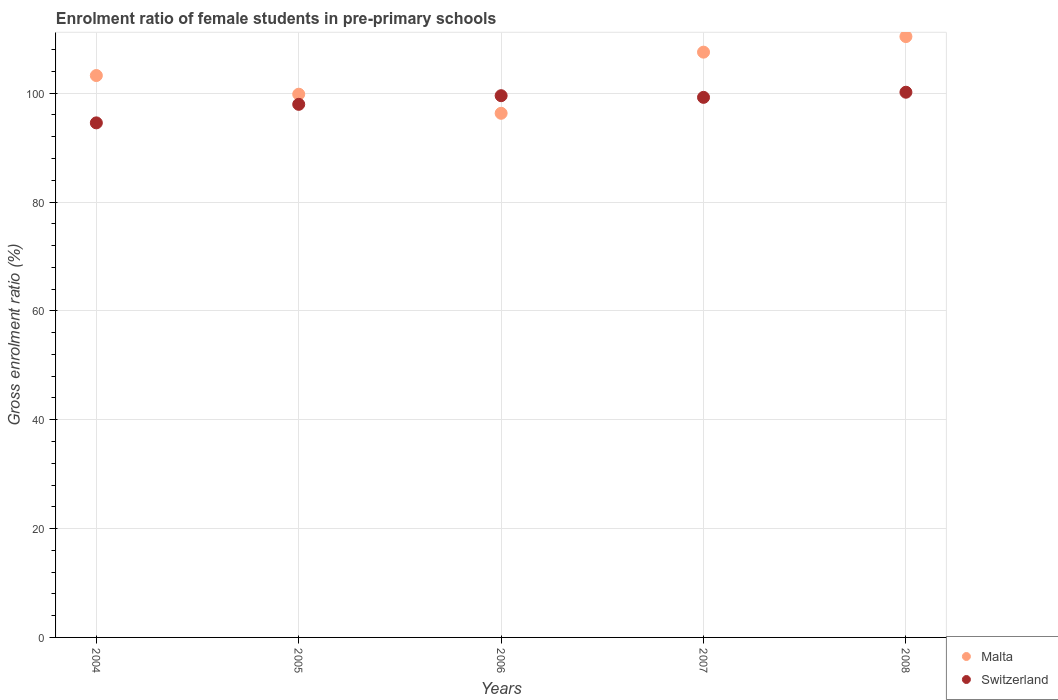How many different coloured dotlines are there?
Your answer should be very brief. 2. What is the enrolment ratio of female students in pre-primary schools in Switzerland in 2004?
Offer a very short reply. 94.55. Across all years, what is the maximum enrolment ratio of female students in pre-primary schools in Malta?
Make the answer very short. 110.4. Across all years, what is the minimum enrolment ratio of female students in pre-primary schools in Malta?
Make the answer very short. 96.31. In which year was the enrolment ratio of female students in pre-primary schools in Malta minimum?
Offer a terse response. 2006. What is the total enrolment ratio of female students in pre-primary schools in Malta in the graph?
Your answer should be compact. 517.31. What is the difference between the enrolment ratio of female students in pre-primary schools in Malta in 2005 and that in 2006?
Give a very brief answer. 3.51. What is the difference between the enrolment ratio of female students in pre-primary schools in Malta in 2006 and the enrolment ratio of female students in pre-primary schools in Switzerland in 2005?
Offer a terse response. -1.65. What is the average enrolment ratio of female students in pre-primary schools in Malta per year?
Offer a very short reply. 103.46. In the year 2004, what is the difference between the enrolment ratio of female students in pre-primary schools in Malta and enrolment ratio of female students in pre-primary schools in Switzerland?
Make the answer very short. 8.7. What is the ratio of the enrolment ratio of female students in pre-primary schools in Malta in 2004 to that in 2008?
Make the answer very short. 0.94. Is the enrolment ratio of female students in pre-primary schools in Malta in 2004 less than that in 2006?
Offer a very short reply. No. Is the difference between the enrolment ratio of female students in pre-primary schools in Malta in 2004 and 2006 greater than the difference between the enrolment ratio of female students in pre-primary schools in Switzerland in 2004 and 2006?
Give a very brief answer. Yes. What is the difference between the highest and the second highest enrolment ratio of female students in pre-primary schools in Malta?
Offer a very short reply. 2.86. What is the difference between the highest and the lowest enrolment ratio of female students in pre-primary schools in Switzerland?
Your response must be concise. 5.63. In how many years, is the enrolment ratio of female students in pre-primary schools in Switzerland greater than the average enrolment ratio of female students in pre-primary schools in Switzerland taken over all years?
Provide a short and direct response. 3. Is the sum of the enrolment ratio of female students in pre-primary schools in Switzerland in 2004 and 2008 greater than the maximum enrolment ratio of female students in pre-primary schools in Malta across all years?
Give a very brief answer. Yes. Is the enrolment ratio of female students in pre-primary schools in Malta strictly greater than the enrolment ratio of female students in pre-primary schools in Switzerland over the years?
Offer a very short reply. No. What is the difference between two consecutive major ticks on the Y-axis?
Your response must be concise. 20. What is the title of the graph?
Your response must be concise. Enrolment ratio of female students in pre-primary schools. What is the Gross enrolment ratio (%) in Malta in 2004?
Ensure brevity in your answer.  103.24. What is the Gross enrolment ratio (%) of Switzerland in 2004?
Ensure brevity in your answer.  94.55. What is the Gross enrolment ratio (%) of Malta in 2005?
Your answer should be very brief. 99.81. What is the Gross enrolment ratio (%) of Switzerland in 2005?
Make the answer very short. 97.95. What is the Gross enrolment ratio (%) in Malta in 2006?
Your answer should be compact. 96.31. What is the Gross enrolment ratio (%) of Switzerland in 2006?
Offer a terse response. 99.54. What is the Gross enrolment ratio (%) of Malta in 2007?
Give a very brief answer. 107.54. What is the Gross enrolment ratio (%) in Switzerland in 2007?
Give a very brief answer. 99.23. What is the Gross enrolment ratio (%) in Malta in 2008?
Provide a succinct answer. 110.4. What is the Gross enrolment ratio (%) in Switzerland in 2008?
Your answer should be compact. 100.18. Across all years, what is the maximum Gross enrolment ratio (%) of Malta?
Offer a terse response. 110.4. Across all years, what is the maximum Gross enrolment ratio (%) of Switzerland?
Offer a terse response. 100.18. Across all years, what is the minimum Gross enrolment ratio (%) of Malta?
Ensure brevity in your answer.  96.31. Across all years, what is the minimum Gross enrolment ratio (%) of Switzerland?
Keep it short and to the point. 94.55. What is the total Gross enrolment ratio (%) in Malta in the graph?
Provide a succinct answer. 517.31. What is the total Gross enrolment ratio (%) of Switzerland in the graph?
Give a very brief answer. 491.45. What is the difference between the Gross enrolment ratio (%) of Malta in 2004 and that in 2005?
Give a very brief answer. 3.43. What is the difference between the Gross enrolment ratio (%) in Switzerland in 2004 and that in 2005?
Make the answer very short. -3.4. What is the difference between the Gross enrolment ratio (%) of Malta in 2004 and that in 2006?
Make the answer very short. 6.94. What is the difference between the Gross enrolment ratio (%) in Switzerland in 2004 and that in 2006?
Give a very brief answer. -4.99. What is the difference between the Gross enrolment ratio (%) in Malta in 2004 and that in 2007?
Ensure brevity in your answer.  -4.3. What is the difference between the Gross enrolment ratio (%) in Switzerland in 2004 and that in 2007?
Offer a very short reply. -4.69. What is the difference between the Gross enrolment ratio (%) of Malta in 2004 and that in 2008?
Make the answer very short. -7.16. What is the difference between the Gross enrolment ratio (%) in Switzerland in 2004 and that in 2008?
Your answer should be compact. -5.63. What is the difference between the Gross enrolment ratio (%) of Malta in 2005 and that in 2006?
Your answer should be very brief. 3.51. What is the difference between the Gross enrolment ratio (%) in Switzerland in 2005 and that in 2006?
Keep it short and to the point. -1.59. What is the difference between the Gross enrolment ratio (%) in Malta in 2005 and that in 2007?
Your answer should be compact. -7.73. What is the difference between the Gross enrolment ratio (%) in Switzerland in 2005 and that in 2007?
Make the answer very short. -1.28. What is the difference between the Gross enrolment ratio (%) of Malta in 2005 and that in 2008?
Provide a succinct answer. -10.59. What is the difference between the Gross enrolment ratio (%) in Switzerland in 2005 and that in 2008?
Make the answer very short. -2.23. What is the difference between the Gross enrolment ratio (%) of Malta in 2006 and that in 2007?
Offer a very short reply. -11.24. What is the difference between the Gross enrolment ratio (%) in Switzerland in 2006 and that in 2007?
Provide a short and direct response. 0.31. What is the difference between the Gross enrolment ratio (%) of Malta in 2006 and that in 2008?
Make the answer very short. -14.1. What is the difference between the Gross enrolment ratio (%) in Switzerland in 2006 and that in 2008?
Provide a succinct answer. -0.64. What is the difference between the Gross enrolment ratio (%) in Malta in 2007 and that in 2008?
Ensure brevity in your answer.  -2.86. What is the difference between the Gross enrolment ratio (%) of Switzerland in 2007 and that in 2008?
Offer a very short reply. -0.94. What is the difference between the Gross enrolment ratio (%) in Malta in 2004 and the Gross enrolment ratio (%) in Switzerland in 2005?
Your answer should be compact. 5.29. What is the difference between the Gross enrolment ratio (%) of Malta in 2004 and the Gross enrolment ratio (%) of Switzerland in 2006?
Provide a succinct answer. 3.7. What is the difference between the Gross enrolment ratio (%) of Malta in 2004 and the Gross enrolment ratio (%) of Switzerland in 2007?
Offer a terse response. 4.01. What is the difference between the Gross enrolment ratio (%) in Malta in 2004 and the Gross enrolment ratio (%) in Switzerland in 2008?
Provide a succinct answer. 3.07. What is the difference between the Gross enrolment ratio (%) in Malta in 2005 and the Gross enrolment ratio (%) in Switzerland in 2006?
Your response must be concise. 0.27. What is the difference between the Gross enrolment ratio (%) in Malta in 2005 and the Gross enrolment ratio (%) in Switzerland in 2007?
Provide a short and direct response. 0.58. What is the difference between the Gross enrolment ratio (%) in Malta in 2005 and the Gross enrolment ratio (%) in Switzerland in 2008?
Provide a short and direct response. -0.37. What is the difference between the Gross enrolment ratio (%) of Malta in 2006 and the Gross enrolment ratio (%) of Switzerland in 2007?
Offer a very short reply. -2.93. What is the difference between the Gross enrolment ratio (%) in Malta in 2006 and the Gross enrolment ratio (%) in Switzerland in 2008?
Provide a short and direct response. -3.87. What is the difference between the Gross enrolment ratio (%) in Malta in 2007 and the Gross enrolment ratio (%) in Switzerland in 2008?
Offer a terse response. 7.36. What is the average Gross enrolment ratio (%) in Malta per year?
Provide a succinct answer. 103.46. What is the average Gross enrolment ratio (%) of Switzerland per year?
Your answer should be compact. 98.29. In the year 2004, what is the difference between the Gross enrolment ratio (%) of Malta and Gross enrolment ratio (%) of Switzerland?
Ensure brevity in your answer.  8.7. In the year 2005, what is the difference between the Gross enrolment ratio (%) in Malta and Gross enrolment ratio (%) in Switzerland?
Ensure brevity in your answer.  1.86. In the year 2006, what is the difference between the Gross enrolment ratio (%) of Malta and Gross enrolment ratio (%) of Switzerland?
Your response must be concise. -3.23. In the year 2007, what is the difference between the Gross enrolment ratio (%) of Malta and Gross enrolment ratio (%) of Switzerland?
Your answer should be very brief. 8.31. In the year 2008, what is the difference between the Gross enrolment ratio (%) in Malta and Gross enrolment ratio (%) in Switzerland?
Your answer should be compact. 10.23. What is the ratio of the Gross enrolment ratio (%) of Malta in 2004 to that in 2005?
Offer a terse response. 1.03. What is the ratio of the Gross enrolment ratio (%) in Switzerland in 2004 to that in 2005?
Your answer should be very brief. 0.97. What is the ratio of the Gross enrolment ratio (%) in Malta in 2004 to that in 2006?
Ensure brevity in your answer.  1.07. What is the ratio of the Gross enrolment ratio (%) of Switzerland in 2004 to that in 2006?
Provide a succinct answer. 0.95. What is the ratio of the Gross enrolment ratio (%) of Switzerland in 2004 to that in 2007?
Offer a very short reply. 0.95. What is the ratio of the Gross enrolment ratio (%) of Malta in 2004 to that in 2008?
Your response must be concise. 0.94. What is the ratio of the Gross enrolment ratio (%) in Switzerland in 2004 to that in 2008?
Give a very brief answer. 0.94. What is the ratio of the Gross enrolment ratio (%) in Malta in 2005 to that in 2006?
Keep it short and to the point. 1.04. What is the ratio of the Gross enrolment ratio (%) in Switzerland in 2005 to that in 2006?
Offer a very short reply. 0.98. What is the ratio of the Gross enrolment ratio (%) of Malta in 2005 to that in 2007?
Offer a very short reply. 0.93. What is the ratio of the Gross enrolment ratio (%) of Switzerland in 2005 to that in 2007?
Provide a short and direct response. 0.99. What is the ratio of the Gross enrolment ratio (%) of Malta in 2005 to that in 2008?
Provide a short and direct response. 0.9. What is the ratio of the Gross enrolment ratio (%) in Switzerland in 2005 to that in 2008?
Give a very brief answer. 0.98. What is the ratio of the Gross enrolment ratio (%) of Malta in 2006 to that in 2007?
Give a very brief answer. 0.9. What is the ratio of the Gross enrolment ratio (%) of Switzerland in 2006 to that in 2007?
Provide a short and direct response. 1. What is the ratio of the Gross enrolment ratio (%) of Malta in 2006 to that in 2008?
Provide a succinct answer. 0.87. What is the ratio of the Gross enrolment ratio (%) in Switzerland in 2006 to that in 2008?
Offer a very short reply. 0.99. What is the ratio of the Gross enrolment ratio (%) of Malta in 2007 to that in 2008?
Provide a succinct answer. 0.97. What is the ratio of the Gross enrolment ratio (%) of Switzerland in 2007 to that in 2008?
Give a very brief answer. 0.99. What is the difference between the highest and the second highest Gross enrolment ratio (%) in Malta?
Keep it short and to the point. 2.86. What is the difference between the highest and the second highest Gross enrolment ratio (%) of Switzerland?
Your response must be concise. 0.64. What is the difference between the highest and the lowest Gross enrolment ratio (%) in Malta?
Provide a succinct answer. 14.1. What is the difference between the highest and the lowest Gross enrolment ratio (%) in Switzerland?
Your answer should be compact. 5.63. 